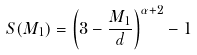<formula> <loc_0><loc_0><loc_500><loc_500>S ( M _ { 1 } ) = \left ( 3 - \frac { M _ { 1 } } { d } \right ) ^ { \alpha + 2 } - 1</formula> 